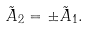Convert formula to latex. <formula><loc_0><loc_0><loc_500><loc_500>\tilde { A } _ { 2 } = \pm \tilde { A } _ { 1 } .</formula> 